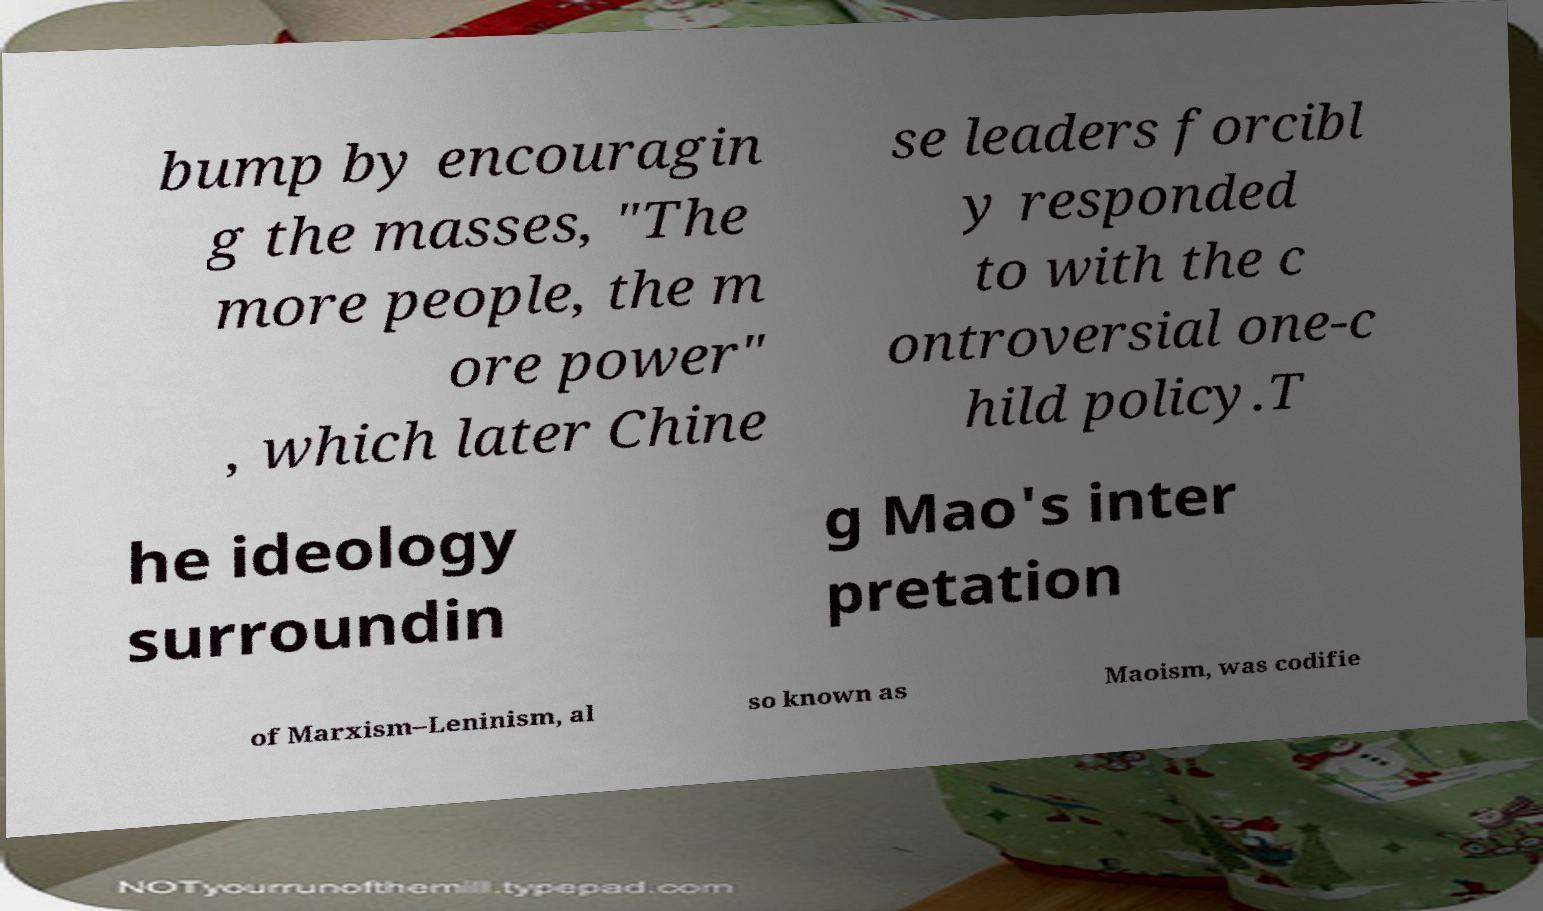Could you extract and type out the text from this image? bump by encouragin g the masses, "The more people, the m ore power" , which later Chine se leaders forcibl y responded to with the c ontroversial one-c hild policy.T he ideology surroundin g Mao's inter pretation of Marxism–Leninism, al so known as Maoism, was codifie 